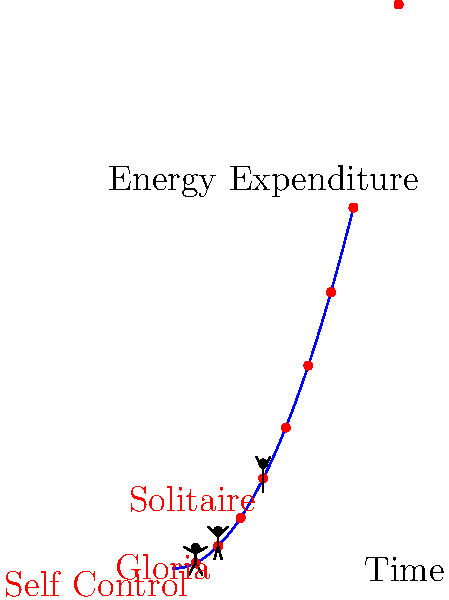In Laura Branigan's music videos, three iconic dance moves from "Self Control," "Gloria," and "Solitaire" are compared based on their energy expenditure over time. The graph shows the relationship between time and energy expenditure for these moves, represented by stick figures. If the energy expenditure follows the equation $E = \frac{1}{2}t^2$, where $E$ is energy and $t$ is time, which dance move requires the most energy at its peak, and how much more energy does it require compared to the least energy-intensive move? To solve this problem, let's follow these steps:

1. Identify the time points for each dance move:
   - Self Control: t = 3.5
   - Gloria: t = 4
   - Solitaire: t = 5

2. Calculate the energy expenditure for each move using $E = \frac{1}{2}t^2$:
   - Self Control: $E = \frac{1}{2}(3.5)^2 = 6.125$
   - Gloria: $E = \frac{1}{2}(4)^2 = 8$
   - Solitaire: $E = \frac{1}{2}(5)^2 = 12.5$

3. Identify the move with the highest energy expenditure:
   Solitaire has the highest energy expenditure at 12.5.

4. Identify the move with the lowest energy expenditure:
   Self Control has the lowest energy expenditure at 6.125.

5. Calculate the difference in energy expenditure:
   $12.5 - 6.125 = 6.375$

Therefore, the dance move from "Solitaire" requires the most energy at its peak, and it requires 6.375 more units of energy compared to the least energy-intensive move from "Self Control."
Answer: Solitaire; 6.375 units more than Self Control 